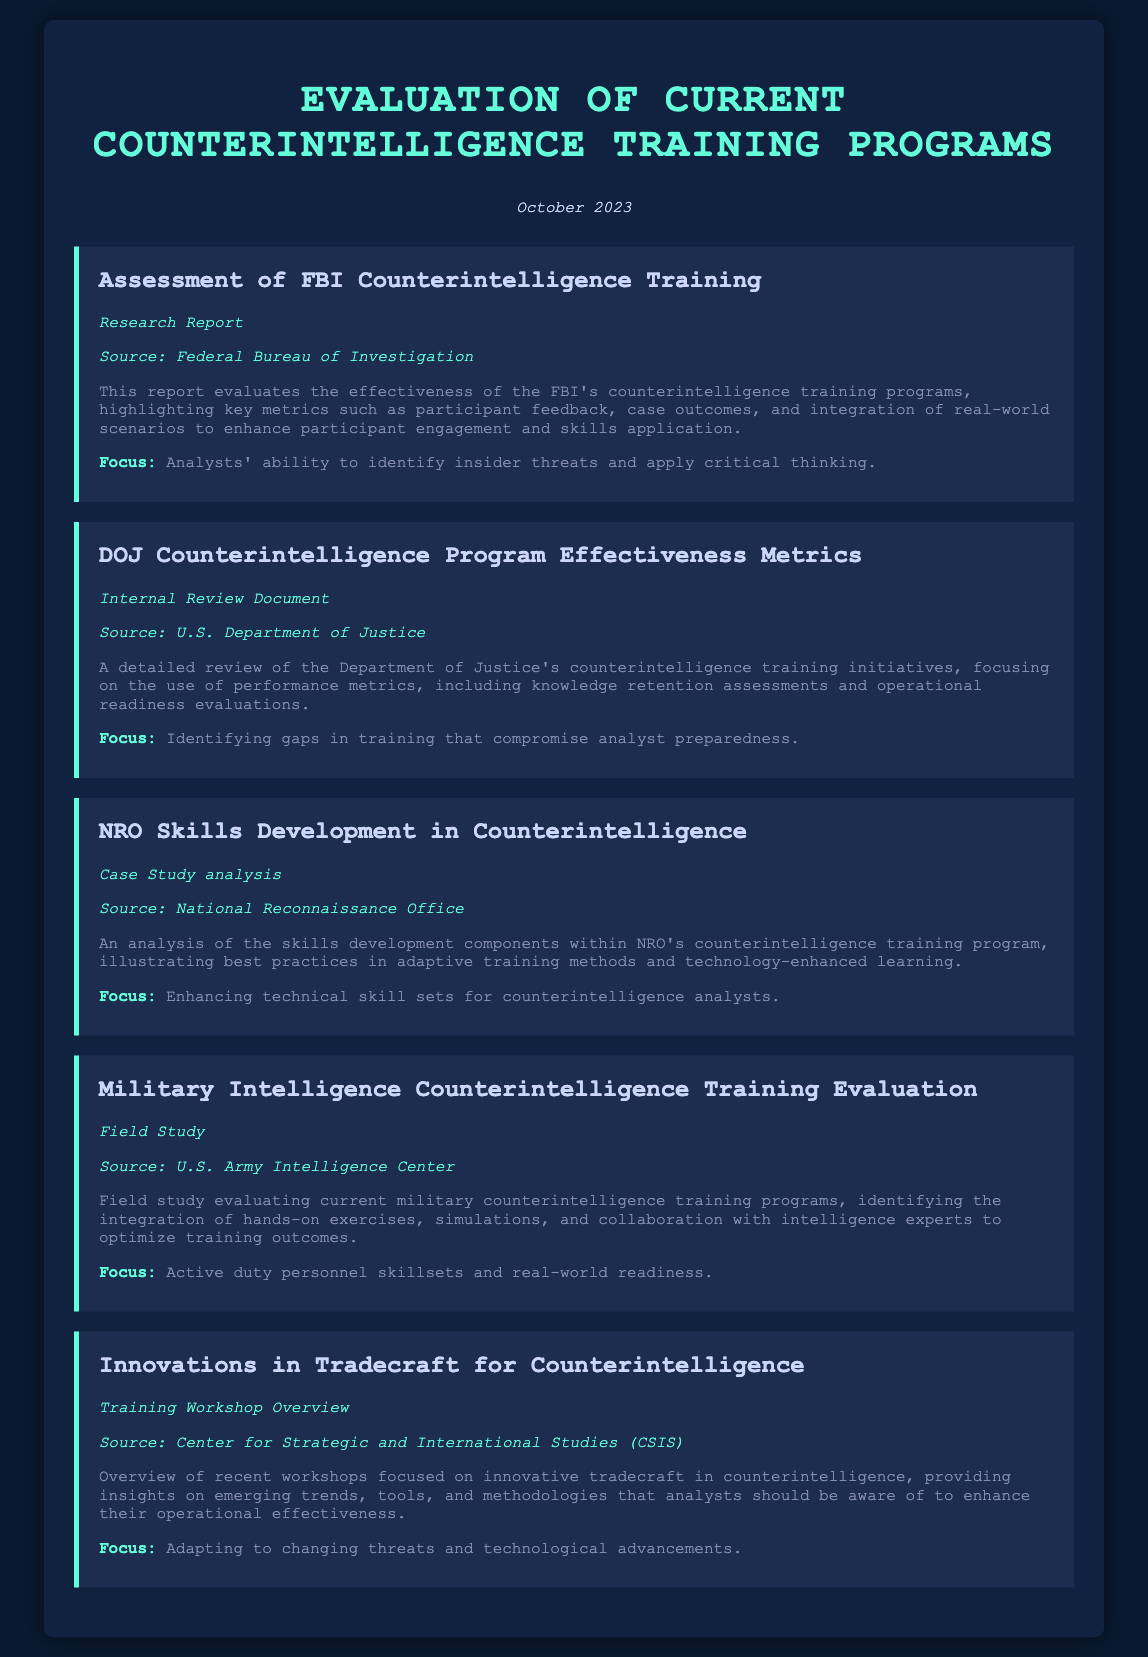What is the title of the document? The title of the document is indicated at the top of the rendered content.
Answer: Evaluation of Current Counterintelligence Training Programs When was the document published? The publication date is displayed prominently in the document.
Answer: October 2023 What is the focus of the FBI Counterintelligence Training report? The focus is described in the summary section of the material related to the FBI training.
Answer: Analysts' ability to identify insider threats and apply critical thinking Who provided the analysis of the skills development components within NRO's counterintelligence training program? The source is stated in the corresponding material section.
Answer: National Reconnaissance Office What type of document is the assessment of DOJ Counterintelligence Program? The type is listed under the document title in the rendered content.
Answer: Internal Review Document What key evaluation metrics are used in the DOJ's counterintelligence training review? Metrics are detailed in the summary section for the DOJ document.
Answer: Knowledge retention assessments and operational readiness evaluations What is the main focus of the Military Intelligence Counterintelligence Training Evaluation? The focus is provided in the summary of that specific material.
Answer: Active duty personnel skillsets and real-world readiness What innovations are discussed in the tradecraft for counterintelligence document? Innovations are briefly highlighted in the document's summary.
Answer: Emerging trends, tools, and methodologies Which organization conducted the training workshops mentioned in the document? The source for the training workshops is given in the specific section of the document.
Answer: Center for Strategic and International Studies (CSIS) 